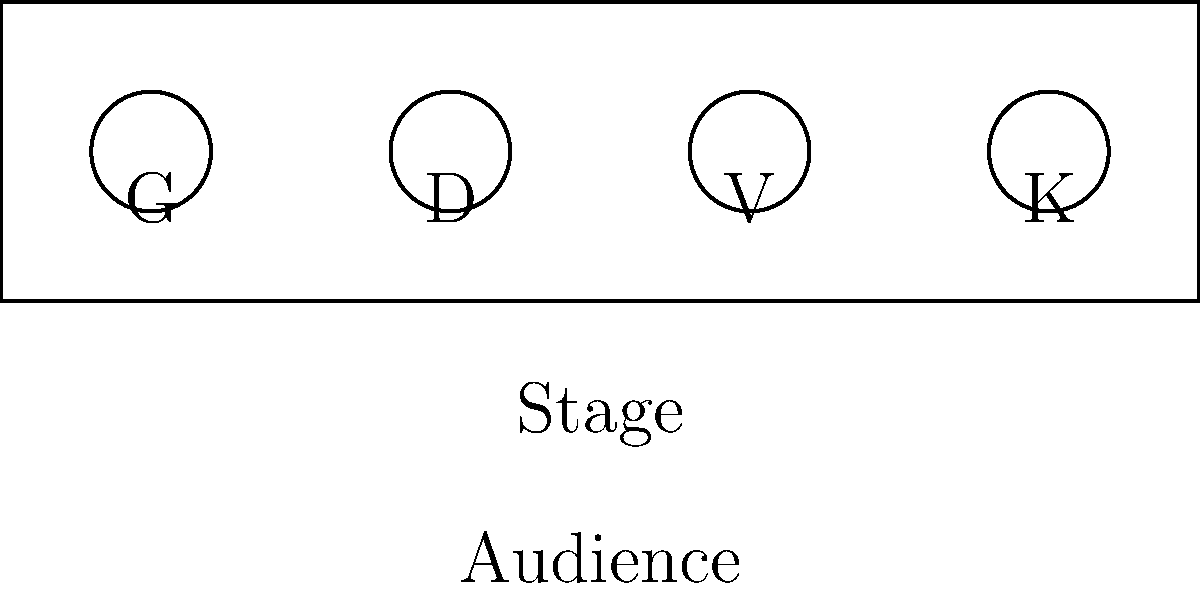During a Tokyo Police Club performance, the band members are positioned on stage as shown in the top-down diagram above. G represents Graham Wright, D is Dave Monks, V is Josh Veck, and K is Greg Alsop. What is the total distance between the two members furthest apart on stage, given that each unit in the diagram represents 2 meters? To solve this problem, we need to follow these steps:

1. Identify the two band members who are furthest apart on stage.
   - From the diagram, we can see that Graham (G) and Greg (K) are at the opposite ends of the stage.

2. Determine the distance between these two members in diagram units.
   - Graham is at position (0,0) and Greg is at position (3,0).
   - The distance between them is 3 units in the diagram.

3. Convert the diagram units to actual distance in meters.
   - We are given that each unit in the diagram represents 2 meters.
   - Therefore, we need to multiply the diagram distance by 2.

4. Calculate the final distance:
   $$ \text{Distance} = 3 \text{ units} \times 2 \text{ meters/unit} = 6 \text{ meters} $$

Thus, the total distance between the two members furthest apart on stage is 6 meters.
Answer: 6 meters 